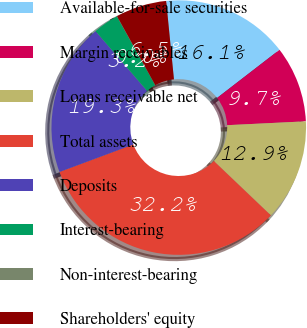Convert chart. <chart><loc_0><loc_0><loc_500><loc_500><pie_chart><fcel>Available-for-sale securities<fcel>Margin receivables<fcel>Loans receivable net<fcel>Total assets<fcel>Deposits<fcel>Interest-bearing<fcel>Non-interest-bearing<fcel>Shareholders' equity<nl><fcel>16.12%<fcel>9.68%<fcel>12.9%<fcel>32.21%<fcel>19.34%<fcel>3.25%<fcel>0.03%<fcel>6.47%<nl></chart> 